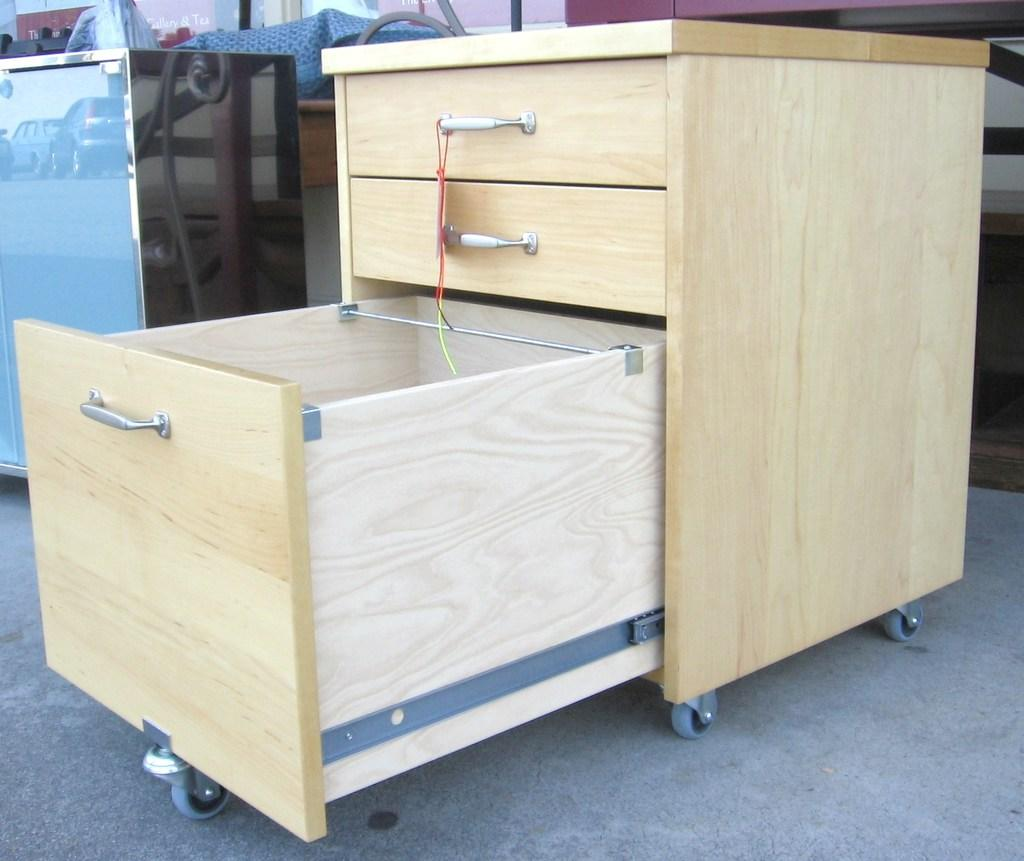What type of furniture is visible in the image? There is a wooden drawer in the image. Where is the wooden drawer located in the image? The wooden drawer is on the right side of the image. What type of battle is taking place on the farm in the image? There is no battle or farm present in the image; it only features a wooden drawer. What type of education is being provided in the image? There is no educational setting or activity depicted in the image; it only features a wooden drawer. 